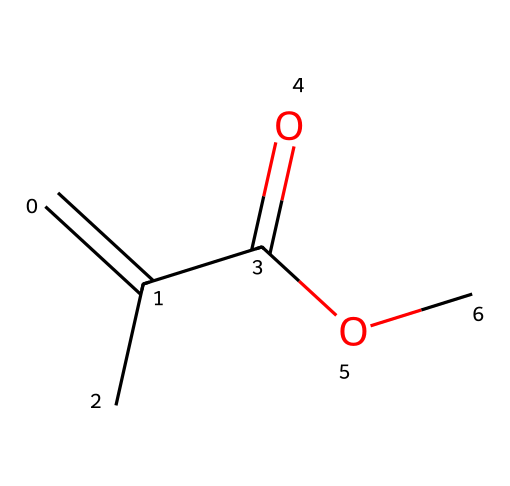What is the molecular formula of this compound? The SMILES representation can be interpreted to count the atoms. The compound includes 5 carbon atoms (C), 8 hydrogen atoms (H), and 2 oxygen atoms (O). Therefore, adding these gives the molecular formula C5H8O2.
Answer: C5H8O2 How many double bonds are present in the structure? By analyzing the SMILES, "C=C" indicates a double bond between two carbon atoms, and there are no other indications of double bonds in the structure. Therefore, there is 1 double bond.
Answer: 1 What functional groups are present in methyl methacrylate? The chemical contains a carbonyl group (C=O) and an ester group indicated by "OC" at the end of the SMILES. Thus, both functional groups can be identified.
Answer: carbonyl and ester How many oxygen atoms are in methyl methacrylate? Observing the SMILES, there's "O" appearing twice, indicating there are two oxygen atoms in the structure.
Answer: 2 What type of polymerization process can methyl methacrylate undergo? Methyl methacrylate is a monomer that typically undergoes free radical polymerization due to the presence of the double bond, enabling it to link into chains.
Answer: free radical polymerization Which atom is at the end of the ester functional group? In the SMILES representation, the "OC" part indicates that the carbon atom is at the end of the ester functional group.
Answer: carbon 